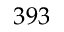<formula> <loc_0><loc_0><loc_500><loc_500>3 9 3</formula> 